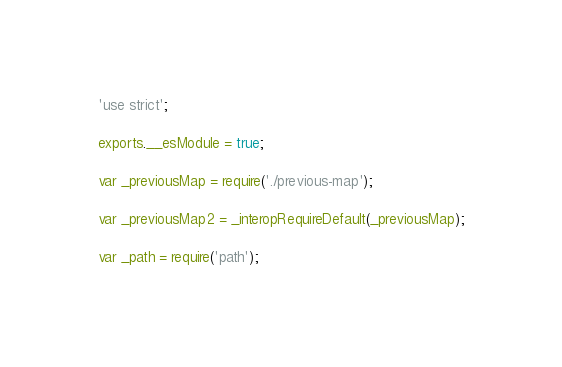<code> <loc_0><loc_0><loc_500><loc_500><_JavaScript_>'use strict';

exports.__esModule = true;

var _previousMap = require('./previous-map');

var _previousMap2 = _interopRequireDefault(_previousMap);

var _path = require('path');
</code> 